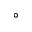Convert formula to latex. <formula><loc_0><loc_0><loc_500><loc_500>^ { \circ }</formula> 